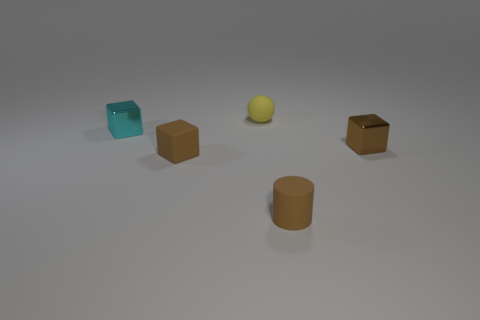Add 2 brown shiny things. How many objects exist? 7 Subtract all cubes. How many objects are left? 2 Subtract 0 green blocks. How many objects are left? 5 Subtract all cyan objects. Subtract all green rubber spheres. How many objects are left? 4 Add 4 yellow objects. How many yellow objects are left? 5 Add 1 small gray blocks. How many small gray blocks exist? 1 